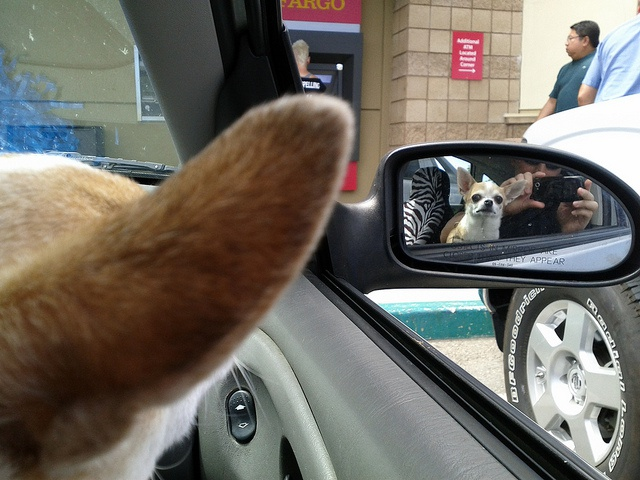Describe the objects in this image and their specific colors. I can see dog in gray, maroon, black, and darkgray tones, car in gray, white, black, and darkgray tones, truck in gray, white, black, and darkgray tones, people in gray and black tones, and people in gray, white, lightblue, and darkgray tones in this image. 